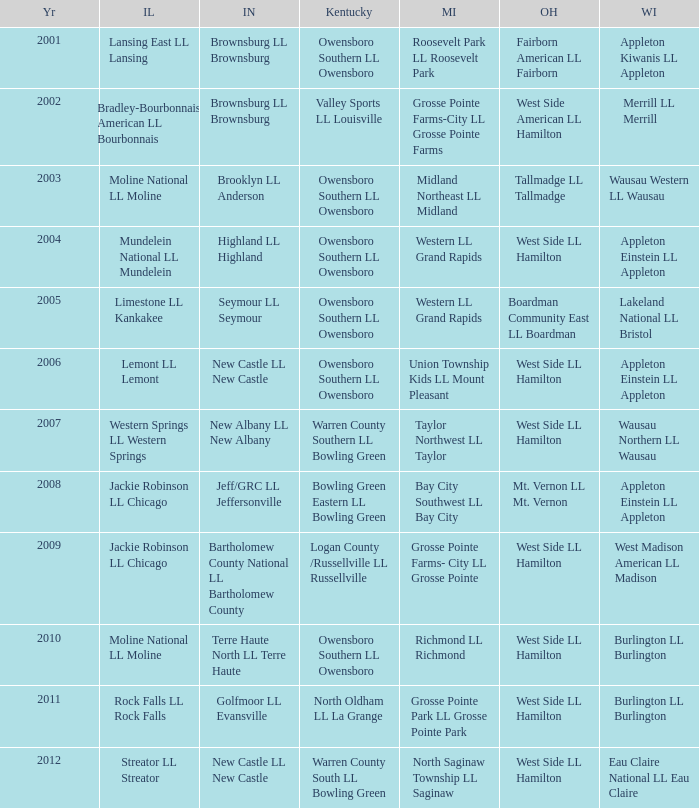Could you help me parse every detail presented in this table? {'header': ['Yr', 'IL', 'IN', 'Kentucky', 'MI', 'OH', 'WI'], 'rows': [['2001', 'Lansing East LL Lansing', 'Brownsburg LL Brownsburg', 'Owensboro Southern LL Owensboro', 'Roosevelt Park LL Roosevelt Park', 'Fairborn American LL Fairborn', 'Appleton Kiwanis LL Appleton'], ['2002', 'Bradley-Bourbonnais American LL Bourbonnais', 'Brownsburg LL Brownsburg', 'Valley Sports LL Louisville', 'Grosse Pointe Farms-City LL Grosse Pointe Farms', 'West Side American LL Hamilton', 'Merrill LL Merrill'], ['2003', 'Moline National LL Moline', 'Brooklyn LL Anderson', 'Owensboro Southern LL Owensboro', 'Midland Northeast LL Midland', 'Tallmadge LL Tallmadge', 'Wausau Western LL Wausau'], ['2004', 'Mundelein National LL Mundelein', 'Highland LL Highland', 'Owensboro Southern LL Owensboro', 'Western LL Grand Rapids', 'West Side LL Hamilton', 'Appleton Einstein LL Appleton'], ['2005', 'Limestone LL Kankakee', 'Seymour LL Seymour', 'Owensboro Southern LL Owensboro', 'Western LL Grand Rapids', 'Boardman Community East LL Boardman', 'Lakeland National LL Bristol'], ['2006', 'Lemont LL Lemont', 'New Castle LL New Castle', 'Owensboro Southern LL Owensboro', 'Union Township Kids LL Mount Pleasant', 'West Side LL Hamilton', 'Appleton Einstein LL Appleton'], ['2007', 'Western Springs LL Western Springs', 'New Albany LL New Albany', 'Warren County Southern LL Bowling Green', 'Taylor Northwest LL Taylor', 'West Side LL Hamilton', 'Wausau Northern LL Wausau'], ['2008', 'Jackie Robinson LL Chicago', 'Jeff/GRC LL Jeffersonville', 'Bowling Green Eastern LL Bowling Green', 'Bay City Southwest LL Bay City', 'Mt. Vernon LL Mt. Vernon', 'Appleton Einstein LL Appleton'], ['2009', 'Jackie Robinson LL Chicago', 'Bartholomew County National LL Bartholomew County', 'Logan County /Russellville LL Russellville', 'Grosse Pointe Farms- City LL Grosse Pointe', 'West Side LL Hamilton', 'West Madison American LL Madison'], ['2010', 'Moline National LL Moline', 'Terre Haute North LL Terre Haute', 'Owensboro Southern LL Owensboro', 'Richmond LL Richmond', 'West Side LL Hamilton', 'Burlington LL Burlington'], ['2011', 'Rock Falls LL Rock Falls', 'Golfmoor LL Evansville', 'North Oldham LL La Grange', 'Grosse Pointe Park LL Grosse Pointe Park', 'West Side LL Hamilton', 'Burlington LL Burlington'], ['2012', 'Streator LL Streator', 'New Castle LL New Castle', 'Warren County South LL Bowling Green', 'North Saginaw Township LL Saginaw', 'West Side LL Hamilton', 'Eau Claire National LL Eau Claire']]} What was the little league team from Indiana when the little league team from Michigan was Midland Northeast LL Midland? Brooklyn LL Anderson. 